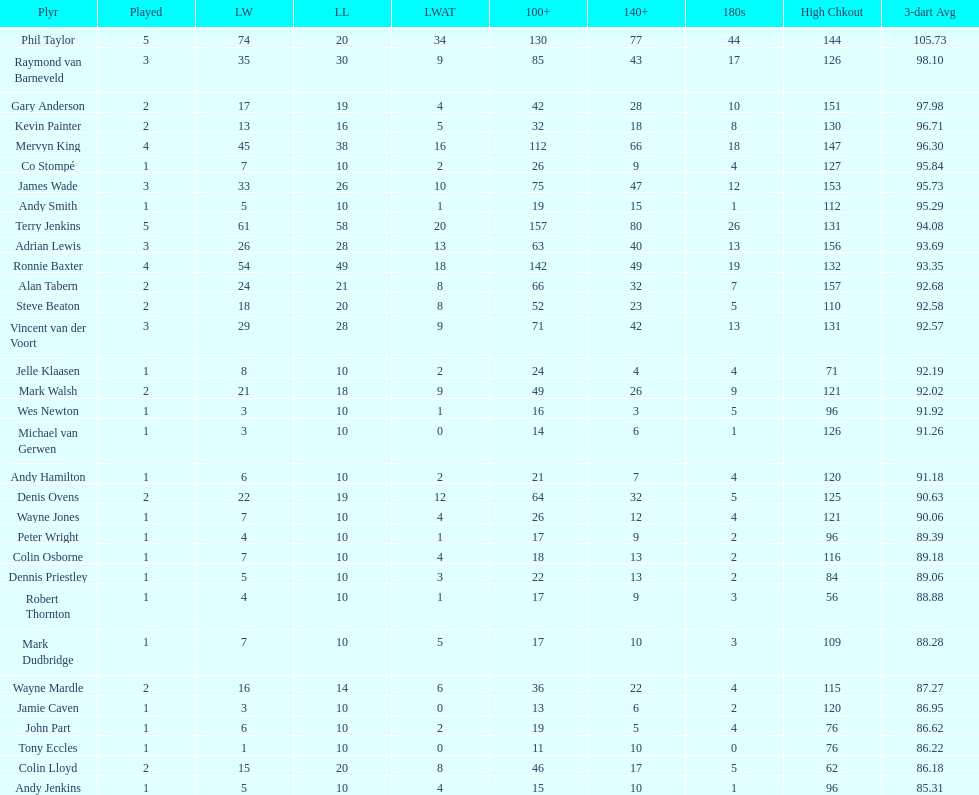How many players have a 3 dart average of more than 97? 3. 